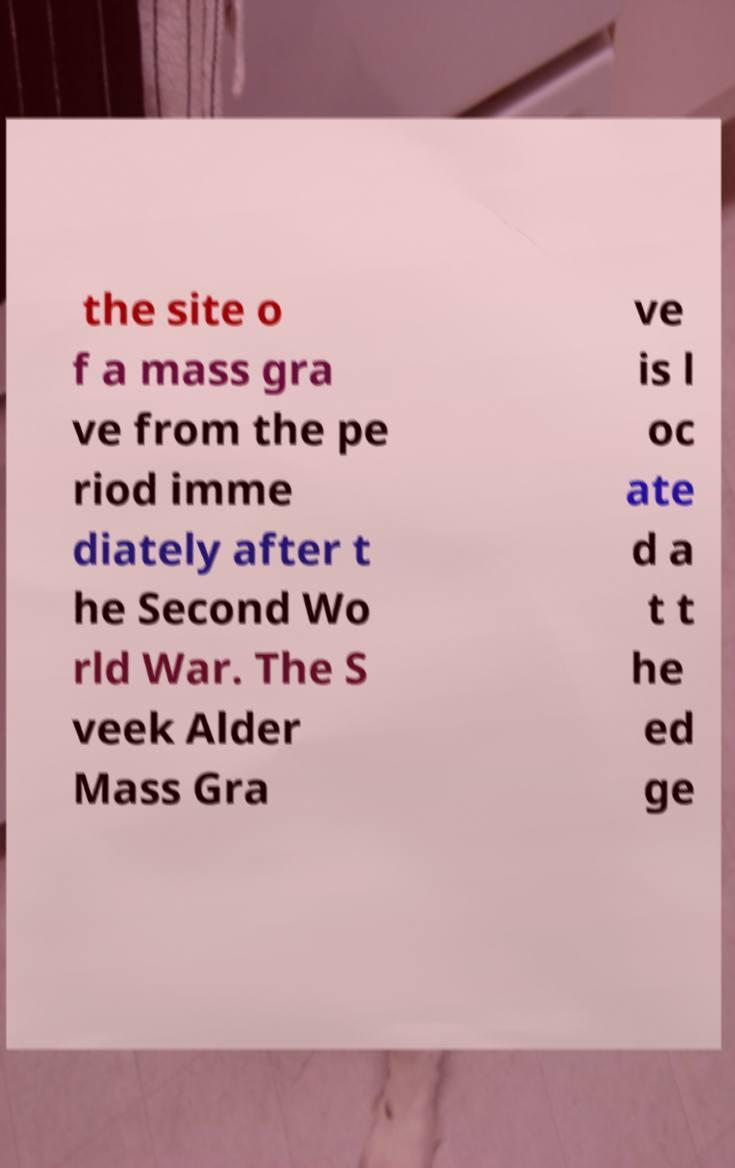I need the written content from this picture converted into text. Can you do that? the site o f a mass gra ve from the pe riod imme diately after t he Second Wo rld War. The S veek Alder Mass Gra ve is l oc ate d a t t he ed ge 